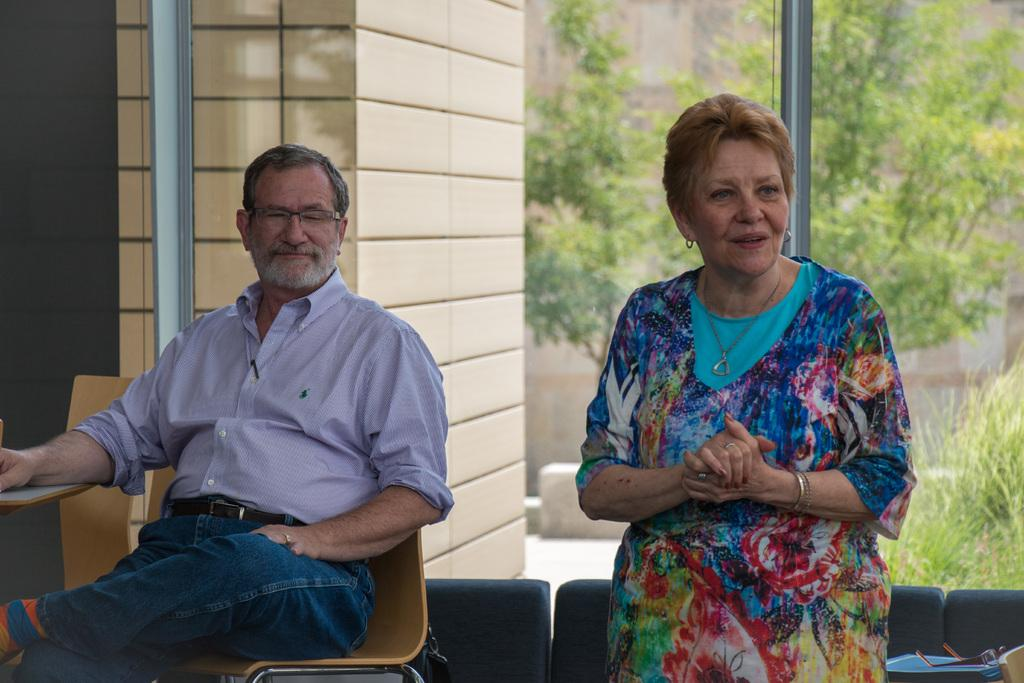Who are the people in the image? There is a man and a woman in the image. What can be seen in the background of the image? There are trees in the background of the image. What type of oil is being used by the man in the image? There is no oil present in the image, and the man is not using any oil. 